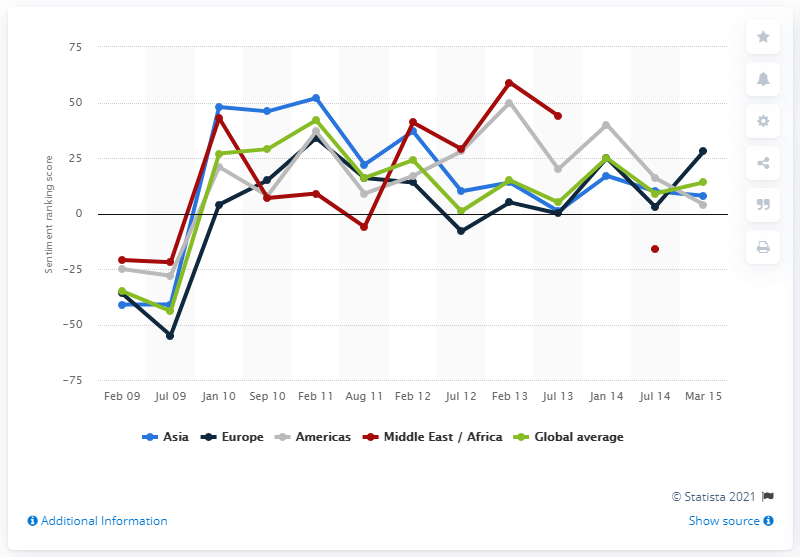Draw attention to some important aspects in this diagram. The sentiment ranking score of hotels in the Americas in January 2014 was 40. 